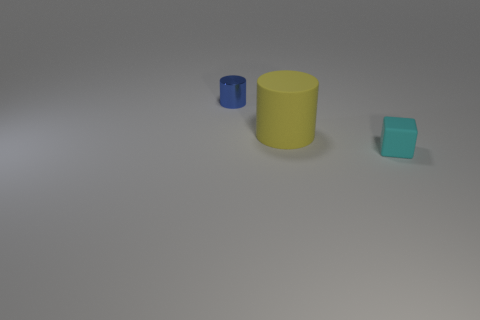Add 3 big matte objects. How many objects exist? 6 Subtract all cylinders. How many objects are left? 1 Subtract all yellow cylinders. How many cylinders are left? 1 Add 2 small cyan matte objects. How many small cyan matte objects are left? 3 Add 2 cyan rubber cylinders. How many cyan rubber cylinders exist? 2 Subtract 0 brown cylinders. How many objects are left? 3 Subtract 1 cylinders. How many cylinders are left? 1 Subtract all yellow cylinders. Subtract all blue spheres. How many cylinders are left? 1 Subtract all tiny cyan blocks. Subtract all green objects. How many objects are left? 2 